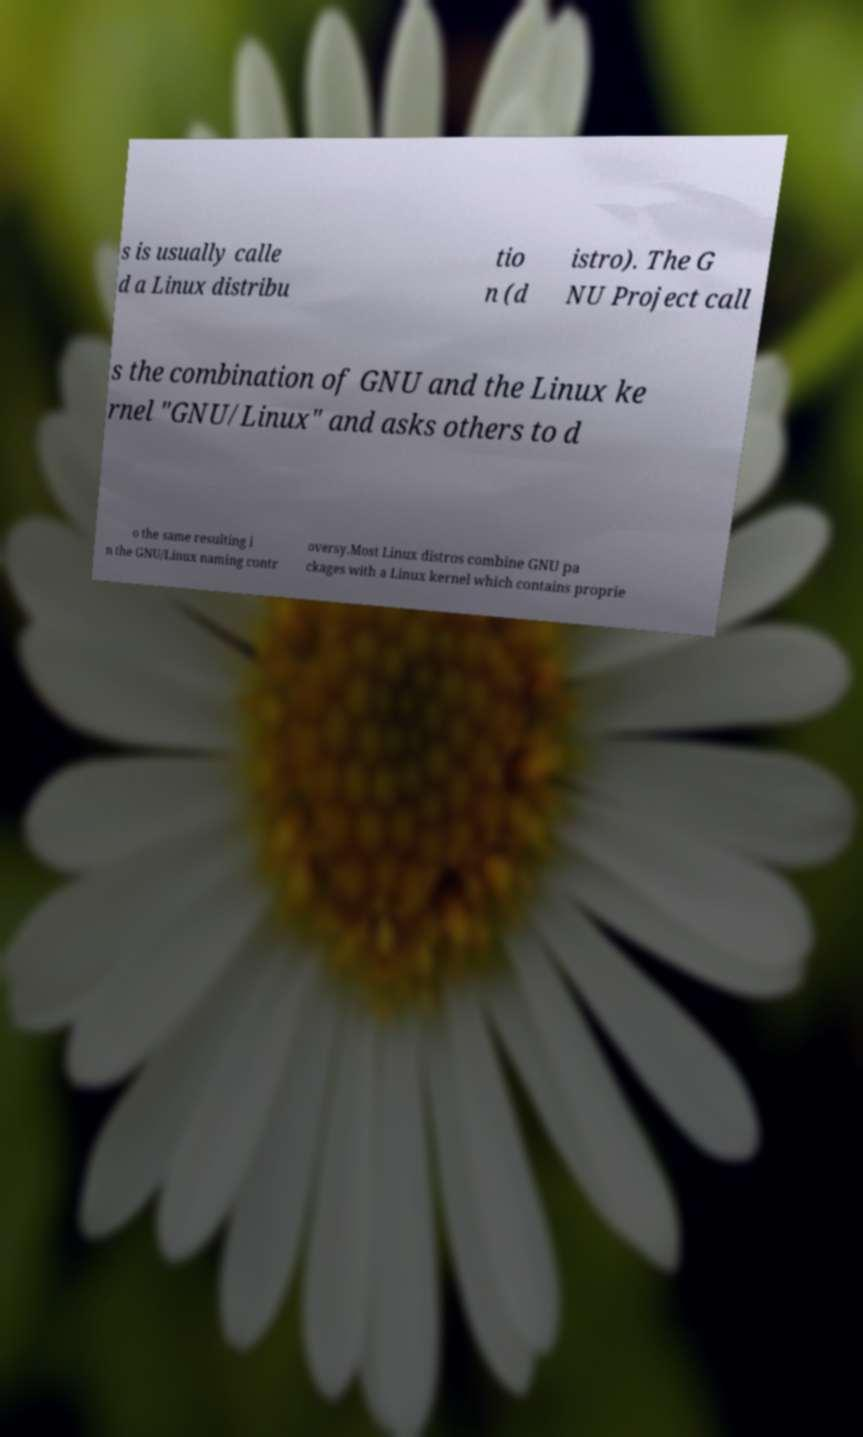I need the written content from this picture converted into text. Can you do that? s is usually calle d a Linux distribu tio n (d istro). The G NU Project call s the combination of GNU and the Linux ke rnel "GNU/Linux" and asks others to d o the same resulting i n the GNU/Linux naming contr oversy.Most Linux distros combine GNU pa ckages with a Linux kernel which contains proprie 